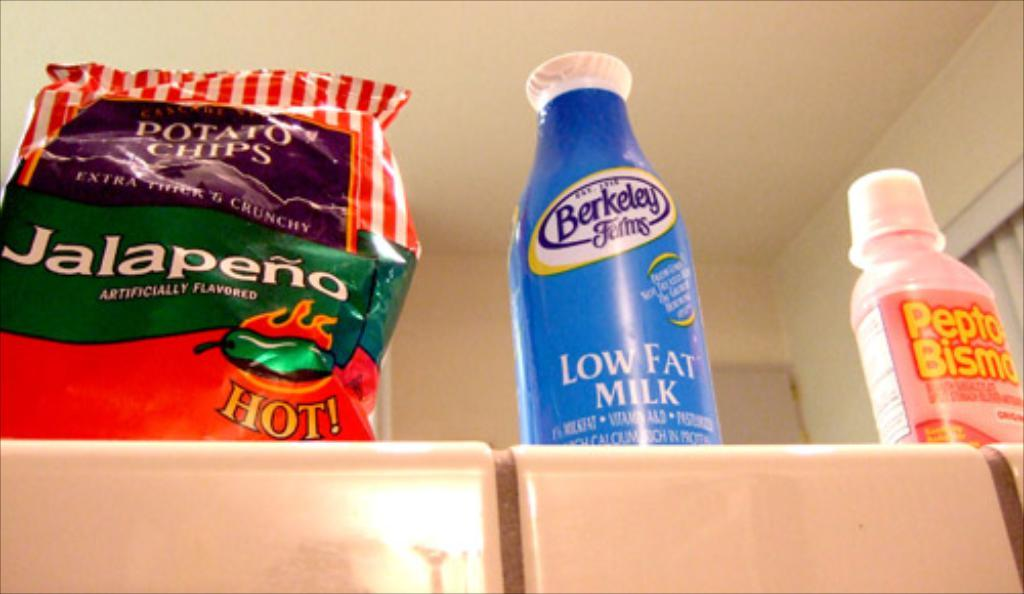<image>
Present a compact description of the photo's key features. A bag of jalapeno potato chips sits next to a bottle of milk. 